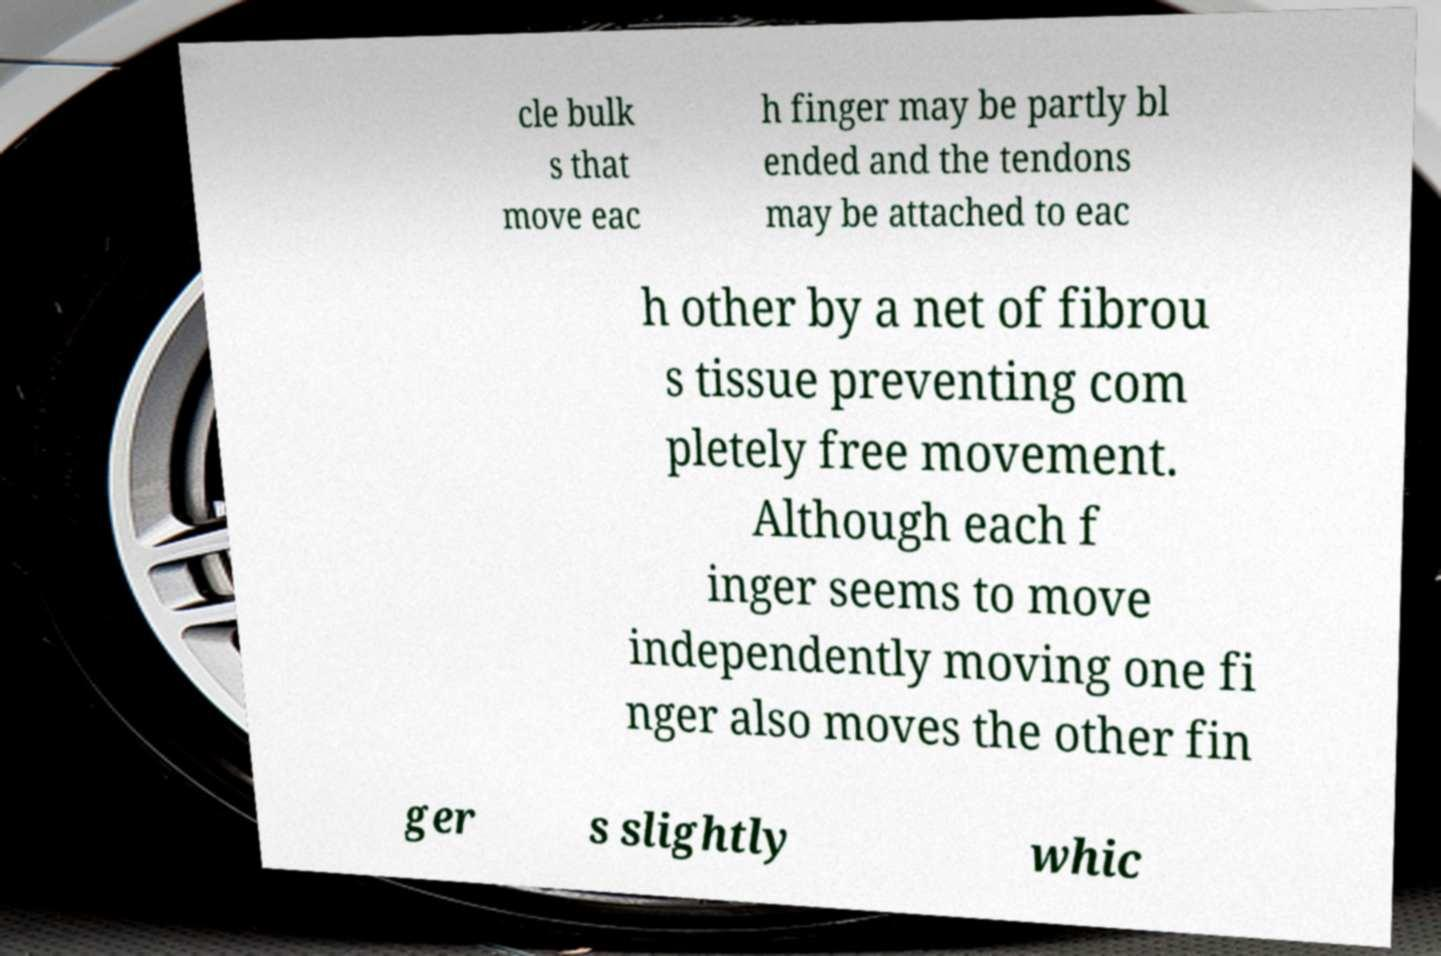Could you assist in decoding the text presented in this image and type it out clearly? cle bulk s that move eac h finger may be partly bl ended and the tendons may be attached to eac h other by a net of fibrou s tissue preventing com pletely free movement. Although each f inger seems to move independently moving one fi nger also moves the other fin ger s slightly whic 